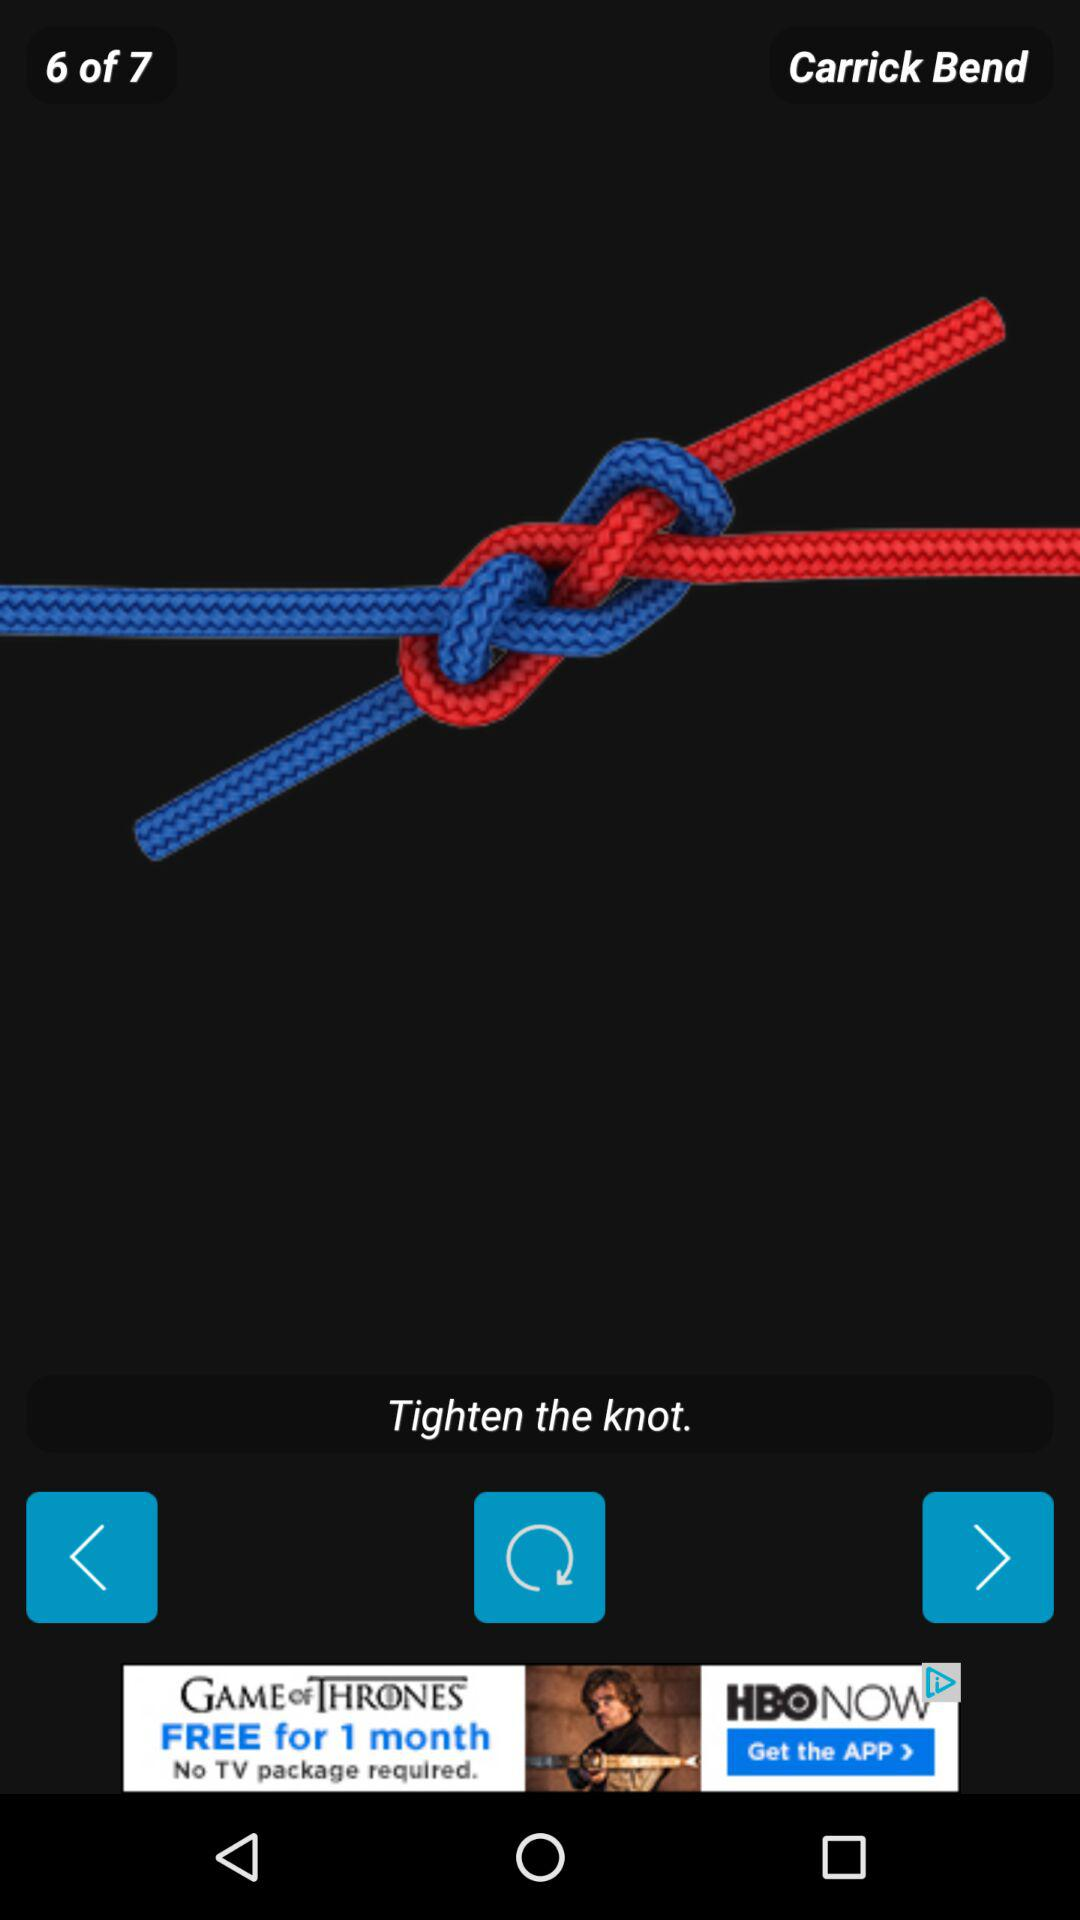What is the name of the bend shown on the screen? The name of the bend is Carrick. 